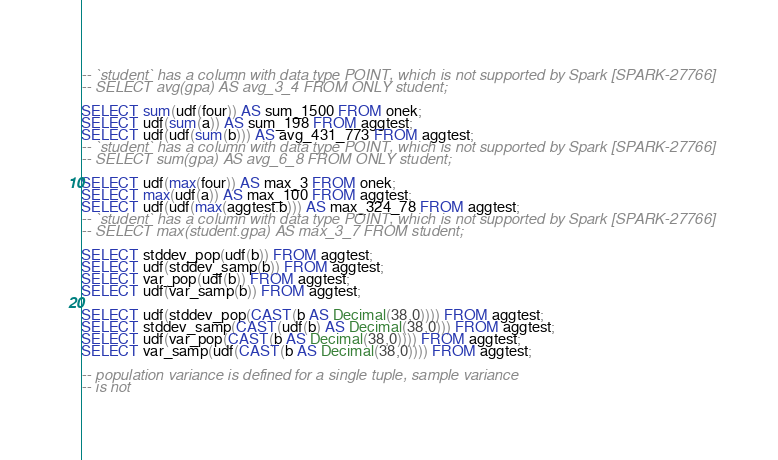Convert code to text. <code><loc_0><loc_0><loc_500><loc_500><_SQL_>-- `student` has a column with data type POINT, which is not supported by Spark [SPARK-27766]
-- SELECT avg(gpa) AS avg_3_4 FROM ONLY student;

SELECT sum(udf(four)) AS sum_1500 FROM onek;
SELECT udf(sum(a)) AS sum_198 FROM aggtest;
SELECT udf(udf(sum(b))) AS avg_431_773 FROM aggtest;
-- `student` has a column with data type POINT, which is not supported by Spark [SPARK-27766]
-- SELECT sum(gpa) AS avg_6_8 FROM ONLY student;

SELECT udf(max(four)) AS max_3 FROM onek;
SELECT max(udf(a)) AS max_100 FROM aggtest;
SELECT udf(udf(max(aggtest.b))) AS max_324_78 FROM aggtest;
-- `student` has a column with data type POINT, which is not supported by Spark [SPARK-27766]
-- SELECT max(student.gpa) AS max_3_7 FROM student;

SELECT stddev_pop(udf(b)) FROM aggtest;
SELECT udf(stddev_samp(b)) FROM aggtest;
SELECT var_pop(udf(b)) FROM aggtest;
SELECT udf(var_samp(b)) FROM aggtest;

SELECT udf(stddev_pop(CAST(b AS Decimal(38,0)))) FROM aggtest;
SELECT stddev_samp(CAST(udf(b) AS Decimal(38,0))) FROM aggtest;
SELECT udf(var_pop(CAST(b AS Decimal(38,0)))) FROM aggtest;
SELECT var_samp(udf(CAST(b AS Decimal(38,0)))) FROM aggtest;

-- population variance is defined for a single tuple, sample variance
-- is not</code> 